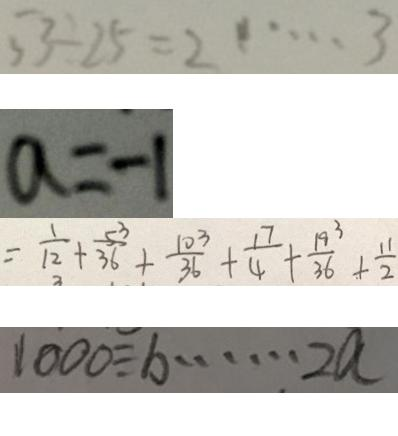<formula> <loc_0><loc_0><loc_500><loc_500>5 3 \div 2 5 = 2 \cdots 3 
 a = - 1 
 = \frac { 1 } { 1 2 } + \frac { 5 3 } { 3 6 } + \frac { 1 0 3 } { 3 6 } + \frac { 1 7 } { 4 } + \frac { 1 9 3 } { 3 6 } + \frac { 1 1 } { 2 } 
 1 0 0 0 \div b \cdots 2 a</formula> 